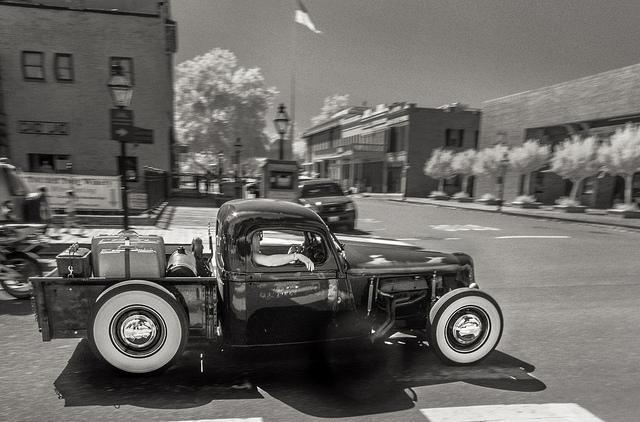How many flags are there?
Give a very brief answer. 1. How many suitcases are there?
Give a very brief answer. 1. How many trucks are there?
Give a very brief answer. 1. 